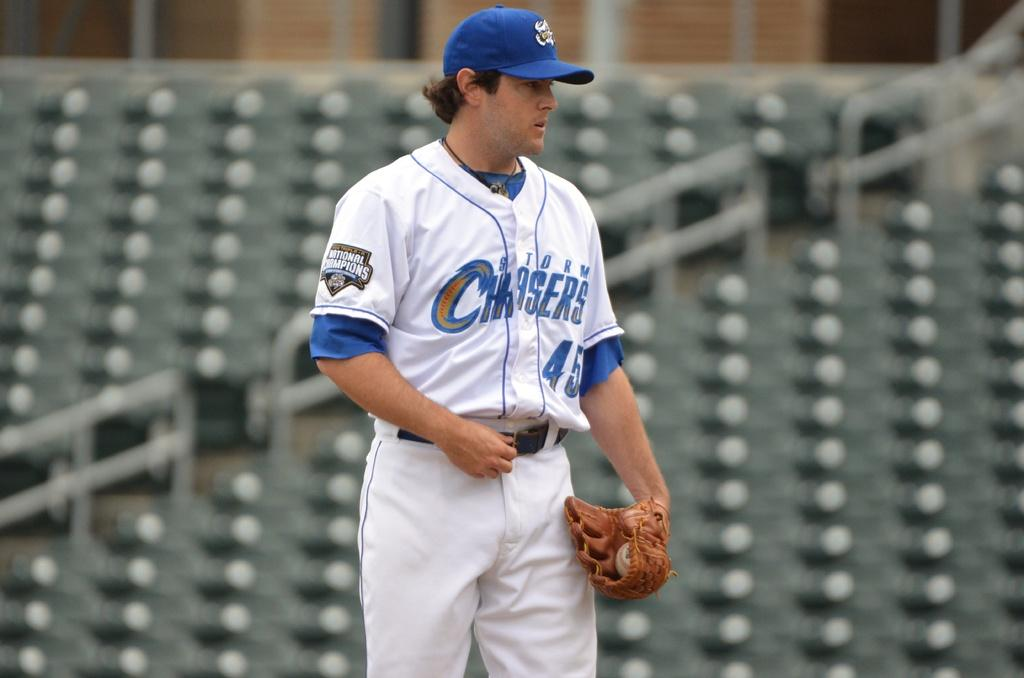<image>
Present a compact description of the photo's key features. A baseball player wearing a Storm Chasers uniform. 